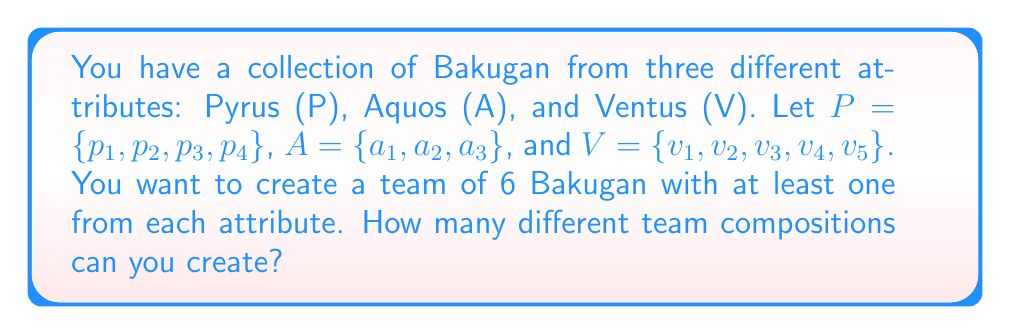Can you answer this question? Let's approach this step-by-step using set theory and combinatorics:

1) First, we need to ensure we have at least one Bakugan from each attribute. Let's consider the remaining 3 spots as "free choices".

2) For the mandatory selections:
   - We have 4 choices for Pyrus (P)
   - 3 choices for Aquos (A)
   - 5 choices for Ventus (V)

3) For the remaining 3 spots, we can choose from all 12 Bakugan ($|P \cup A \cup V| = 4 + 3 + 5 = 12$).

4) We can use the multiplication principle here. The number of ways to select the mandatory Bakugan is:

   $4 \times 3 \times 5 = 60$

5) For the remaining 3 spots, we're selecting 3 out of 12 Bakugan, where order doesn't matter and repetition is not allowed. This is a combination problem, denoted as $\binom{12}{3}$.

6) $\binom{12}{3} = \frac{12!}{3!(12-3)!} = \frac{12!}{3!9!} = 220$

7) By the multiplication principle, the total number of possible team compositions is:

   $60 \times 220 = 13,200$

Therefore, you can create 13,200 different team compositions.
Answer: 13,200 different team compositions 